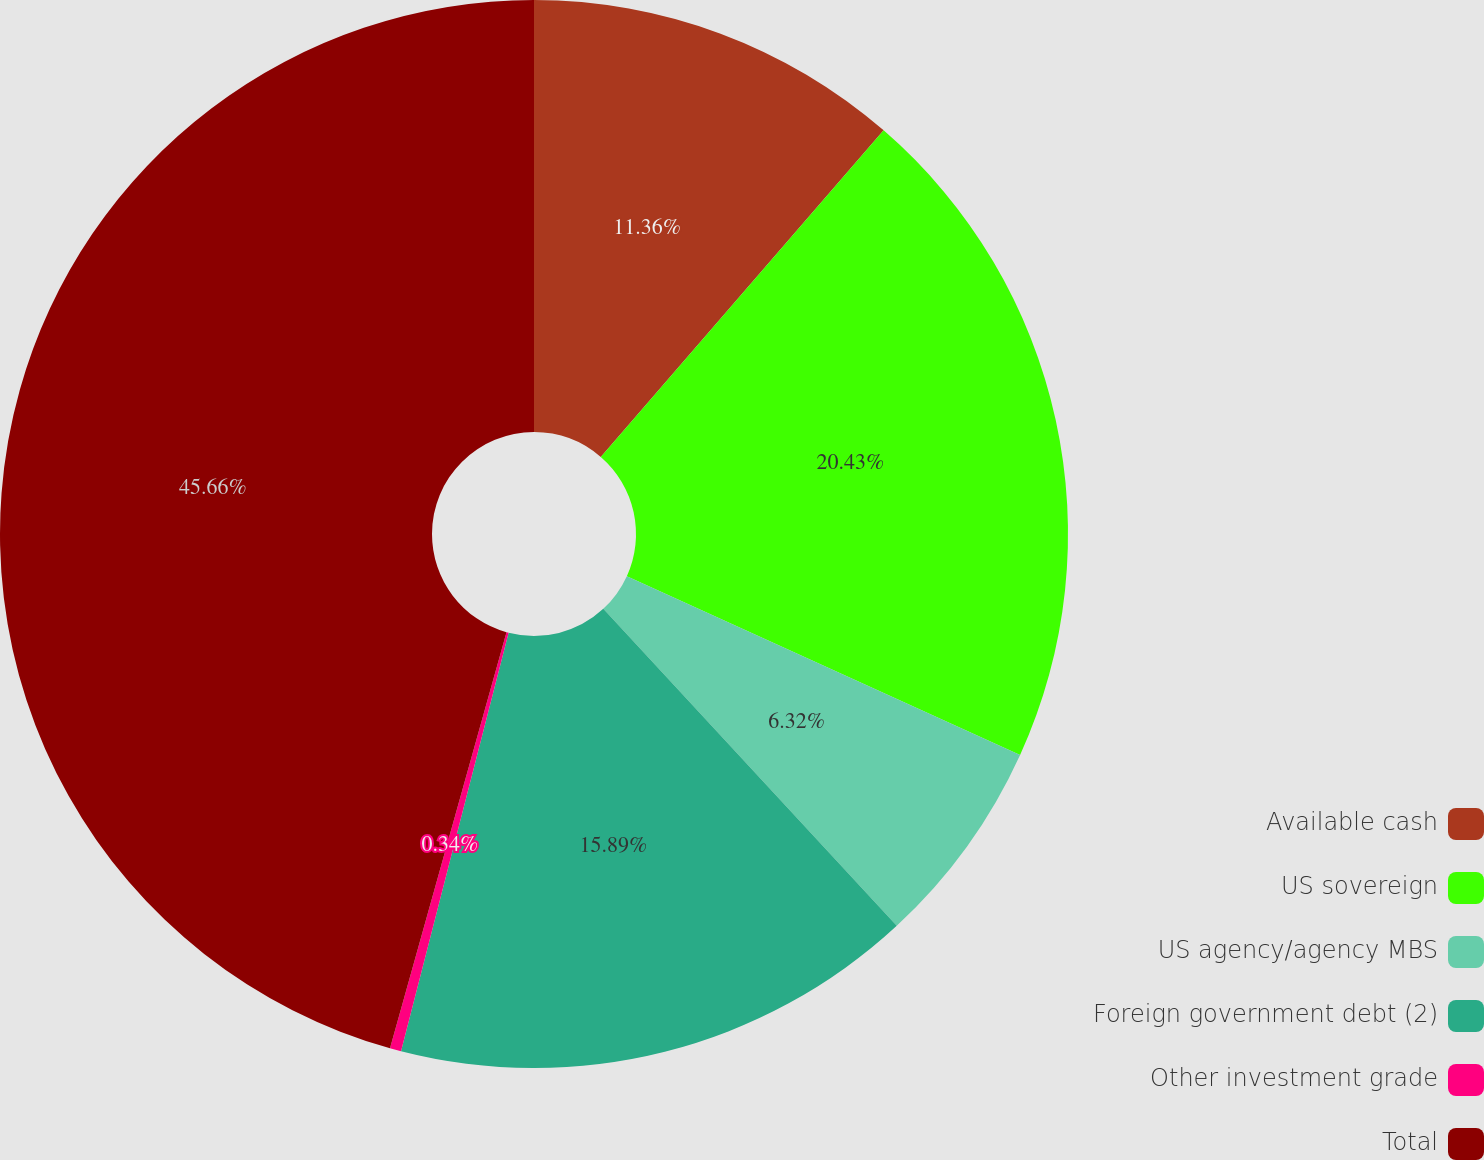<chart> <loc_0><loc_0><loc_500><loc_500><pie_chart><fcel>Available cash<fcel>US sovereign<fcel>US agency/agency MBS<fcel>Foreign government debt (2)<fcel>Other investment grade<fcel>Total<nl><fcel>11.36%<fcel>20.43%<fcel>6.32%<fcel>15.89%<fcel>0.34%<fcel>45.65%<nl></chart> 